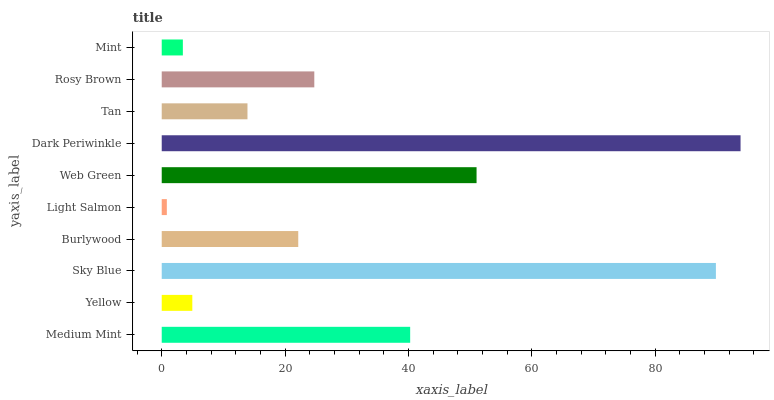Is Light Salmon the minimum?
Answer yes or no. Yes. Is Dark Periwinkle the maximum?
Answer yes or no. Yes. Is Yellow the minimum?
Answer yes or no. No. Is Yellow the maximum?
Answer yes or no. No. Is Medium Mint greater than Yellow?
Answer yes or no. Yes. Is Yellow less than Medium Mint?
Answer yes or no. Yes. Is Yellow greater than Medium Mint?
Answer yes or no. No. Is Medium Mint less than Yellow?
Answer yes or no. No. Is Rosy Brown the high median?
Answer yes or no. Yes. Is Burlywood the low median?
Answer yes or no. Yes. Is Tan the high median?
Answer yes or no. No. Is Tan the low median?
Answer yes or no. No. 